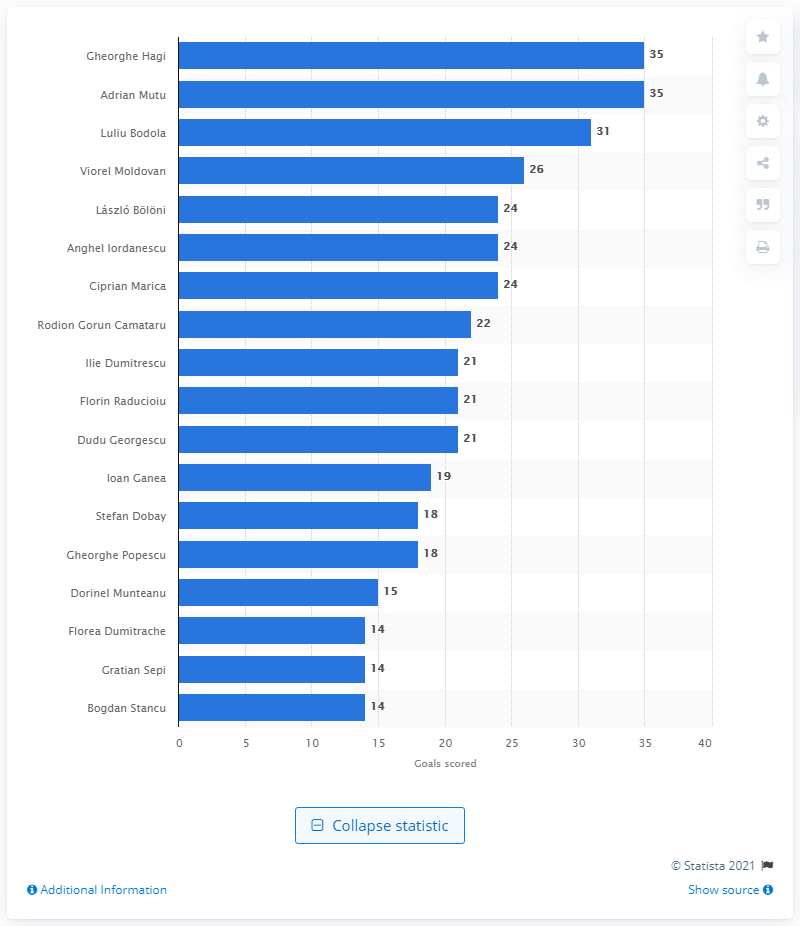Point out several critical features in this image. Adrian Mutu retired from the Romanian national football team in 2013. Gheorghe Hagi retired from the Romanian national football team in 2000. 